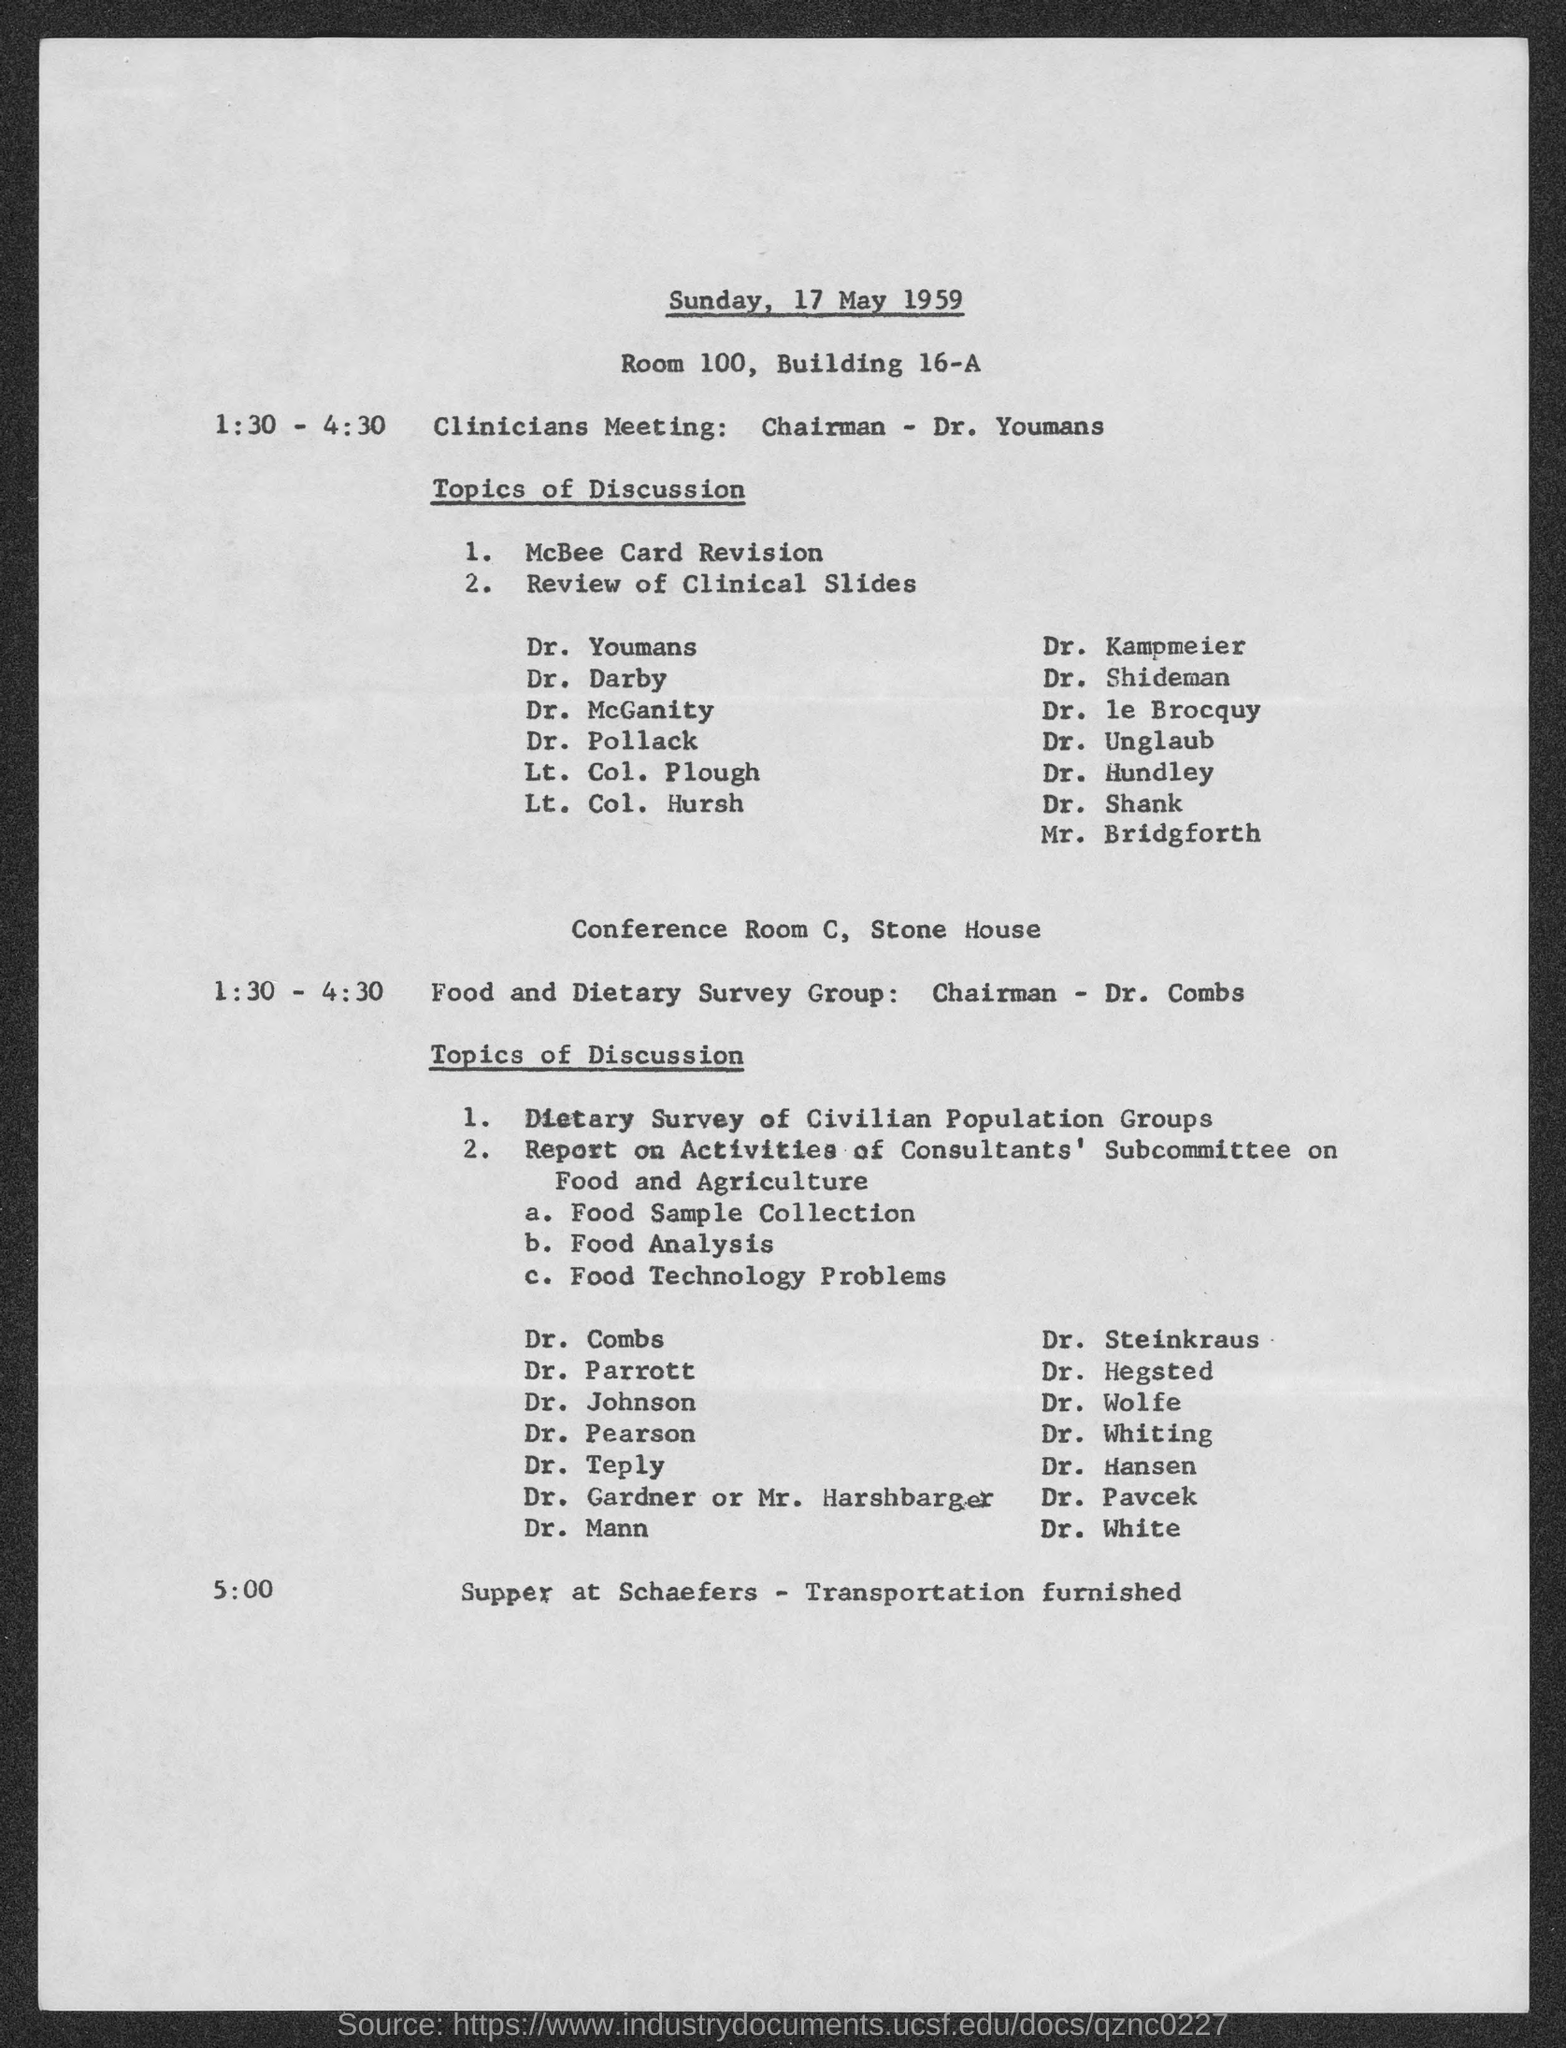What is the time of clinicians meeting?
Give a very brief answer. 1:30 - 4:30. What is the time of  Food and dietary survey group?
Offer a very short reply. 1:30 - 4:30. What is the day and date of meeting?
Provide a short and direct response. Sunday, 17 May 1959. 